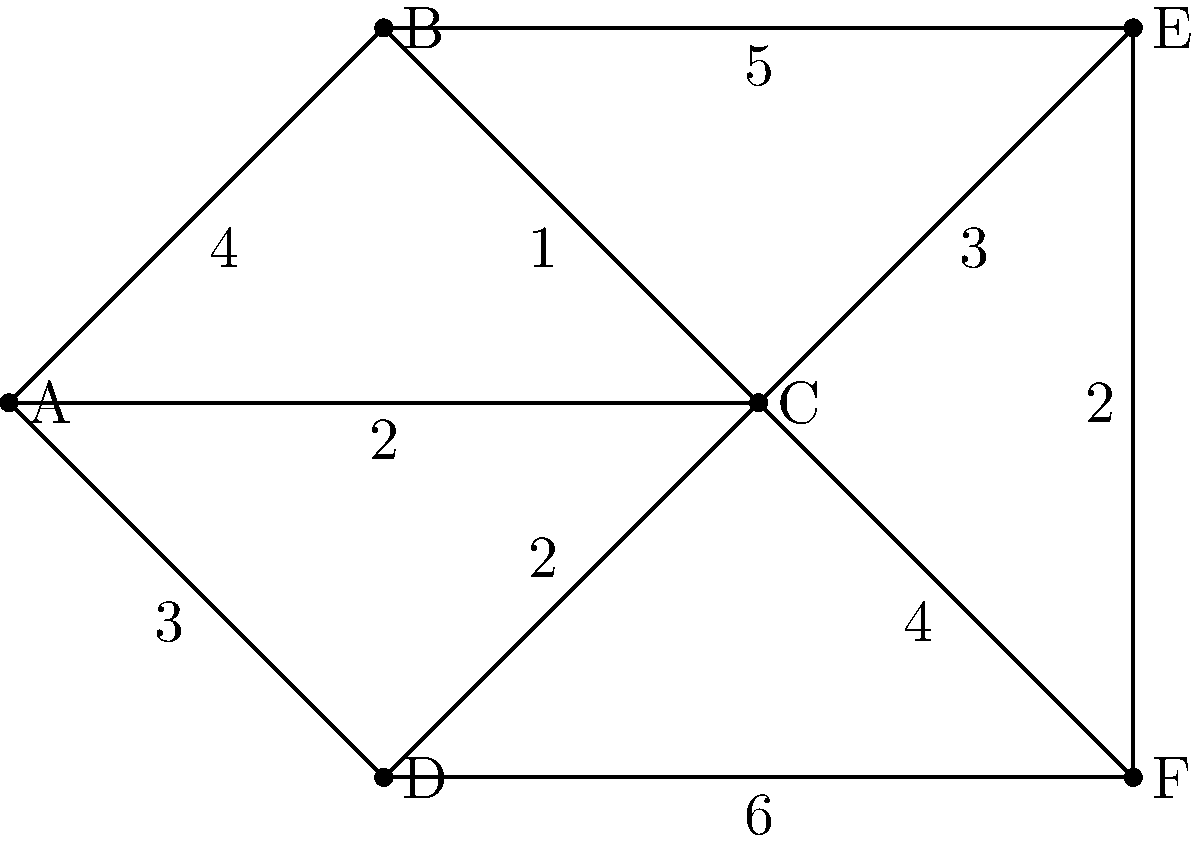As a software developer working on a network optimization project, you're tasked with finding the minimum spanning tree (MST) of the given network topology. Each edge is labeled with its weight. What is the total weight of the MST for this network? To find the minimum spanning tree (MST) and its total weight, we can use Kruskal's algorithm:

1. Sort all edges by weight in ascending order:
   (B,C): 1
   (C,D): 2
   (E,F): 2
   (A,C): 2
   (A,D): 3
   (C,E): 3
   (A,B): 4
   (C,F): 4
   (B,E): 5
   (D,F): 6

2. Start with an empty MST and add edges in order, skipping those that would create a cycle:
   - Add (B,C): 1
   - Add (C,D): 2
   - Add (E,F): 2
   - Add (A,C): 2
   - Skip (A,D): would create a cycle
   - Add (C,E): 3

3. We now have 5 edges, which is correct for an MST of a 6-vertex graph (n-1 edges, where n is the number of vertices).

4. Sum the weights of the selected edges:
   1 + 2 + 2 + 2 + 3 = 10

Therefore, the total weight of the MST is 10.
Answer: 10 